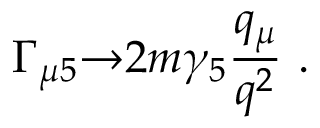<formula> <loc_0><loc_0><loc_500><loc_500>\Gamma _ { \mu 5 } { \rightarrow } 2 m \gamma _ { 5 } { \frac { q _ { \mu } } { q ^ { 2 } } } \ .</formula> 